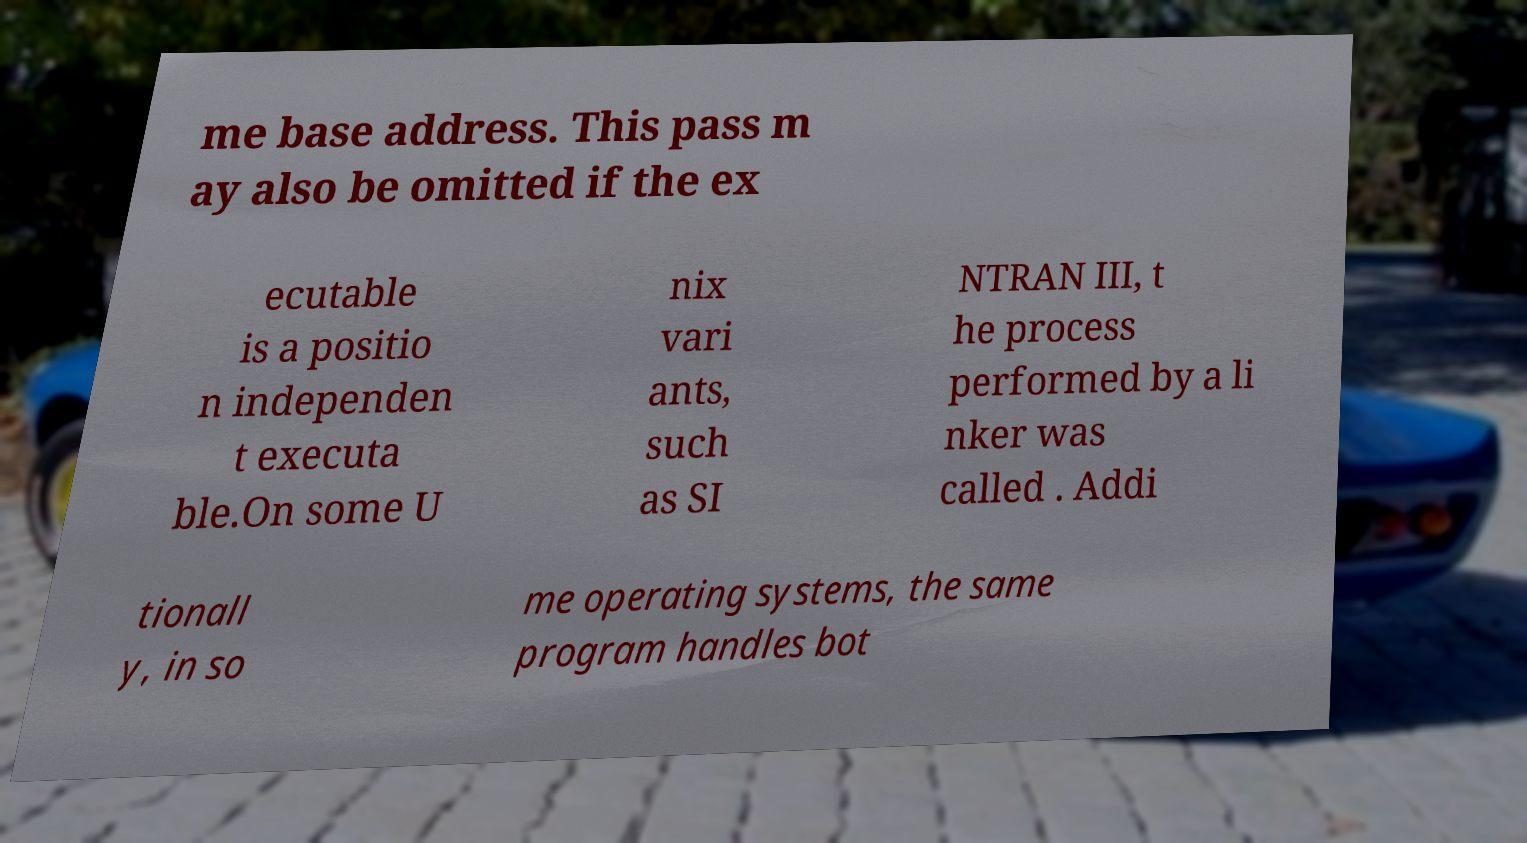I need the written content from this picture converted into text. Can you do that? me base address. This pass m ay also be omitted if the ex ecutable is a positio n independen t executa ble.On some U nix vari ants, such as SI NTRAN III, t he process performed by a li nker was called . Addi tionall y, in so me operating systems, the same program handles bot 